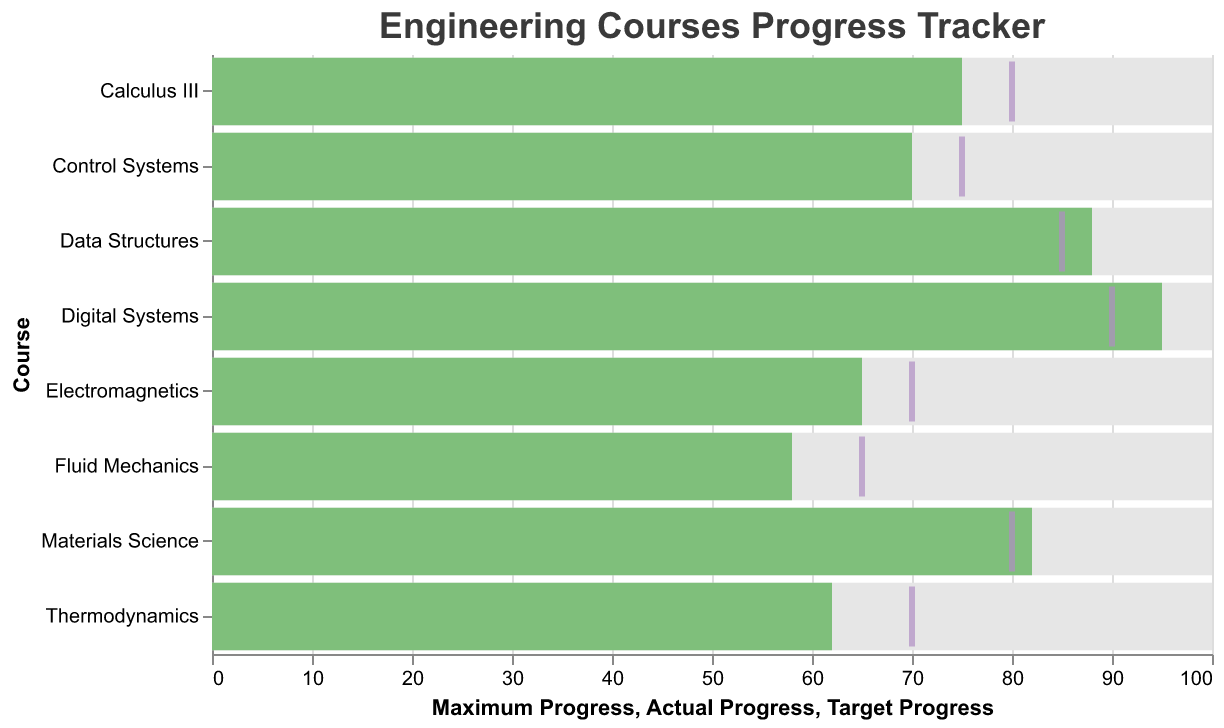What is the title of the chart? The title of the chart is displayed at the top of the figure. It is "Engineering Courses Progress Tracker".
Answer: Engineering Courses Progress Tracker Which course has the highest actual progress? Among all courses, the course with the highest actual progress has the tallest green bar. In this chart, "Digital Systems" has the highest actual progress at 95.
Answer: Digital Systems How many courses met or exceeded their target progress? To determine this, compare the actual progress bar (green) with the target progress tick (purple) for each course. "Data Structures", "Digital Systems", and "Materials Science" have bars reaching or exceeding their ticks.
Answer: 3 What is the difference between the target progress and actual progress for Calculus III? For Calculus III, the target progress is shown by the tick at 80, and the actual progress is shown by the green bar at 75. The difference is 80 - 75 = 5.
Answer: 5 Which course has the largest gap between actual progress and maximum progress? The largest gap can be found by subtracting the actual progress (green bar) from the maximum progress (end of the gray bar) for each course. "Fluid Mechanics" has actual progress at 58 and maximum progress at 100, which gives a gap of 100 - 58 = 42.
Answer: Fluid Mechanics Are there any courses where actual progress is exactly equal to the target progress? To find this, look for courses where the green bar's end aligns exactly with the purple tick mark. No such course is present in this chart.
Answer: No Which course comes closest to meeting its target progress but still falls short? For this, compare the difference between actual progress and target progress for the courses that didn't meet their targets. "Calculus III" with an actual progress of 75 and a target of 80 falls short by the smallest margin: 80 - 75 = 5.
Answer: Calculus III In which course is the difference between actual progress and target progress the largest? For each course, calculate the difference where actual progress falls short of target progress. "Thermodynamics" has an actual progress of 62 and a target of 70, resulting in the largest difference: 70 - 62 = 8.
Answer: Thermodynamics What percentage of the target progress did Fluid Mechanics achieve? Calculate the ratio of actual progress to target progress for "Fluid Mechanics" and then convert to a percentage: (Actual Progress / Target Progress) * 100 = (58 / 65) * 100 = ~89.23%.
Answer: ~89.23% 